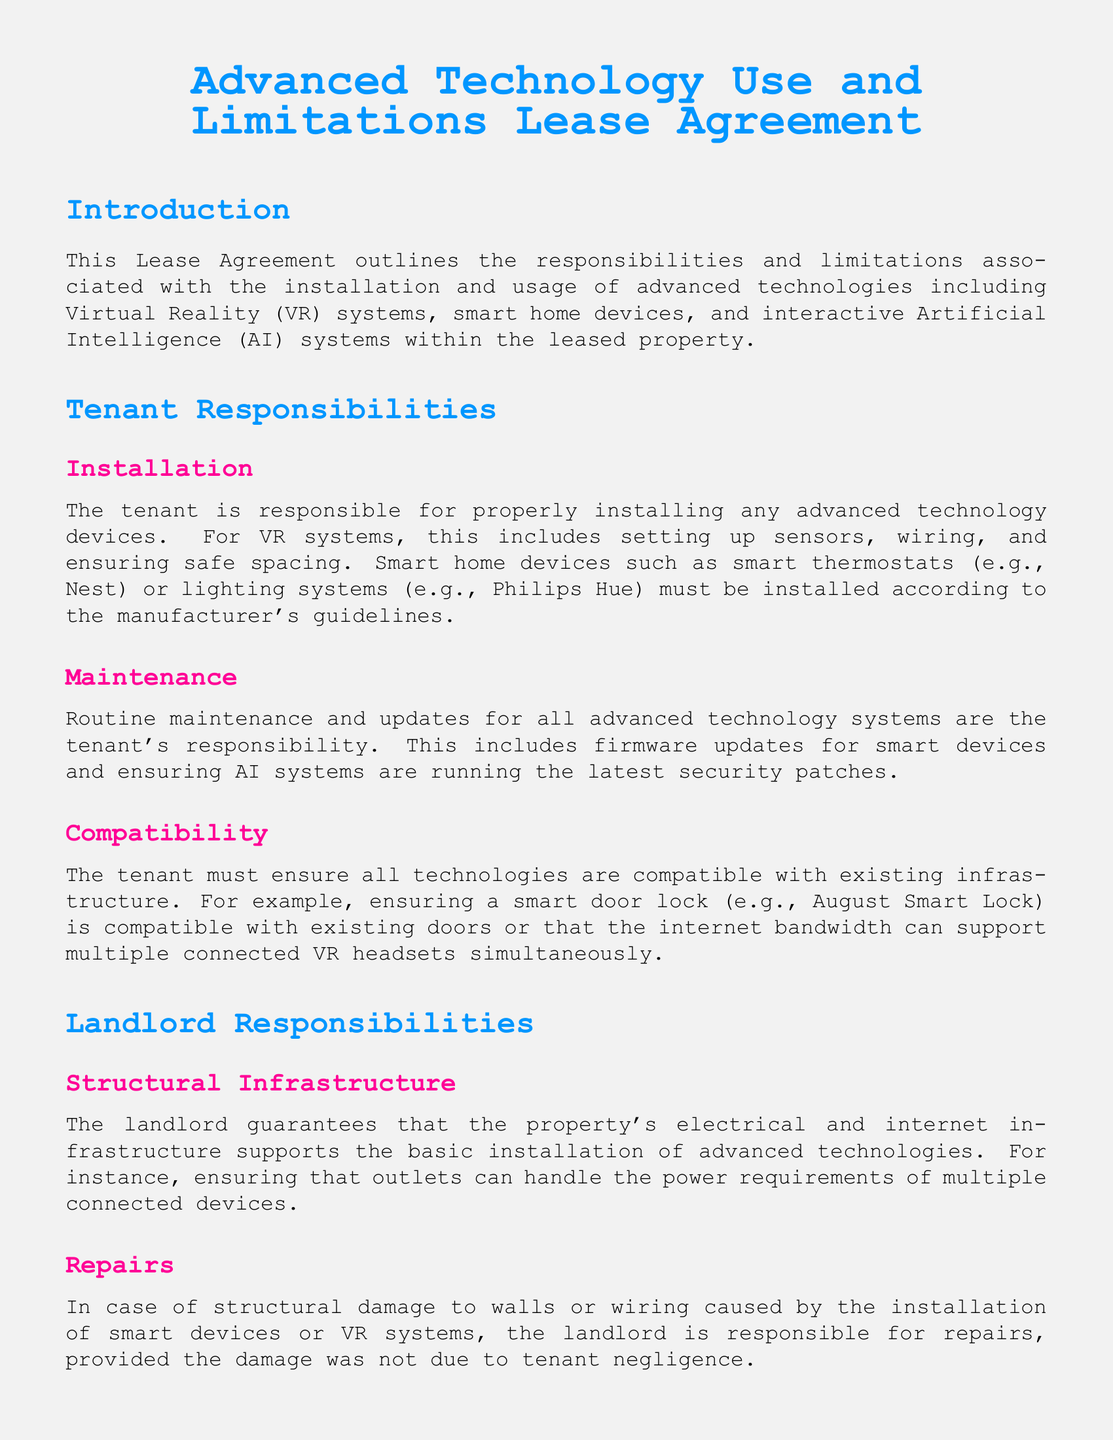What are the tenant's installation responsibilities? The tenant is responsible for properly installing any advanced technology devices according to the manufacturer's guidelines.
Answer: Proper installation Who is responsible for routine maintenance of the advanced technologies? Routine maintenance and updates for all advanced technology systems are the tenant's responsibility.
Answer: Tenant What must the tenant ensure about technology compatibility? The tenant must ensure all technologies are compatible with existing infrastructure.
Answer: Compatibility with existing infrastructure What are the landlord's obligations regarding structural infrastructure? The landlord guarantees that the property's electrical and internet infrastructure supports the basic installation of advanced technologies.
Answer: Supports basic installation What is the tenant's liability for damage resulting from improper use? Any damage resulting from the improper use or installation of advanced technologies is the tenant's responsibility.
Answer: Tenant's responsibility What must happen at the end of the lease regarding installed technologies? At the end of the lease period, the tenant must remove all advanced technology devices and restore the property to its original condition.
Answer: Remove devices How long does the tenant have to remove technologies if the lease is terminated early? If the lease is terminated early, the tenant has 30 days to remove their installed technologies.
Answer: 30 days What type of technologies are covered in the agreement? The agreement covers advanced technologies including Virtual Reality (VR) systems, smart home devices, and interactive Artificial Intelligence (AI) systems.
Answer: Advanced technologies What is the purpose of this lease agreement? This Lease Agreement outlines the responsibilities and limitations associated with the installation and usage of advanced technologies.
Answer: Outline responsibilities and limitations What color is the title in this document? The title is colored scifiblue, which is defined as RGB 0,150,255.
Answer: Scifiblue 